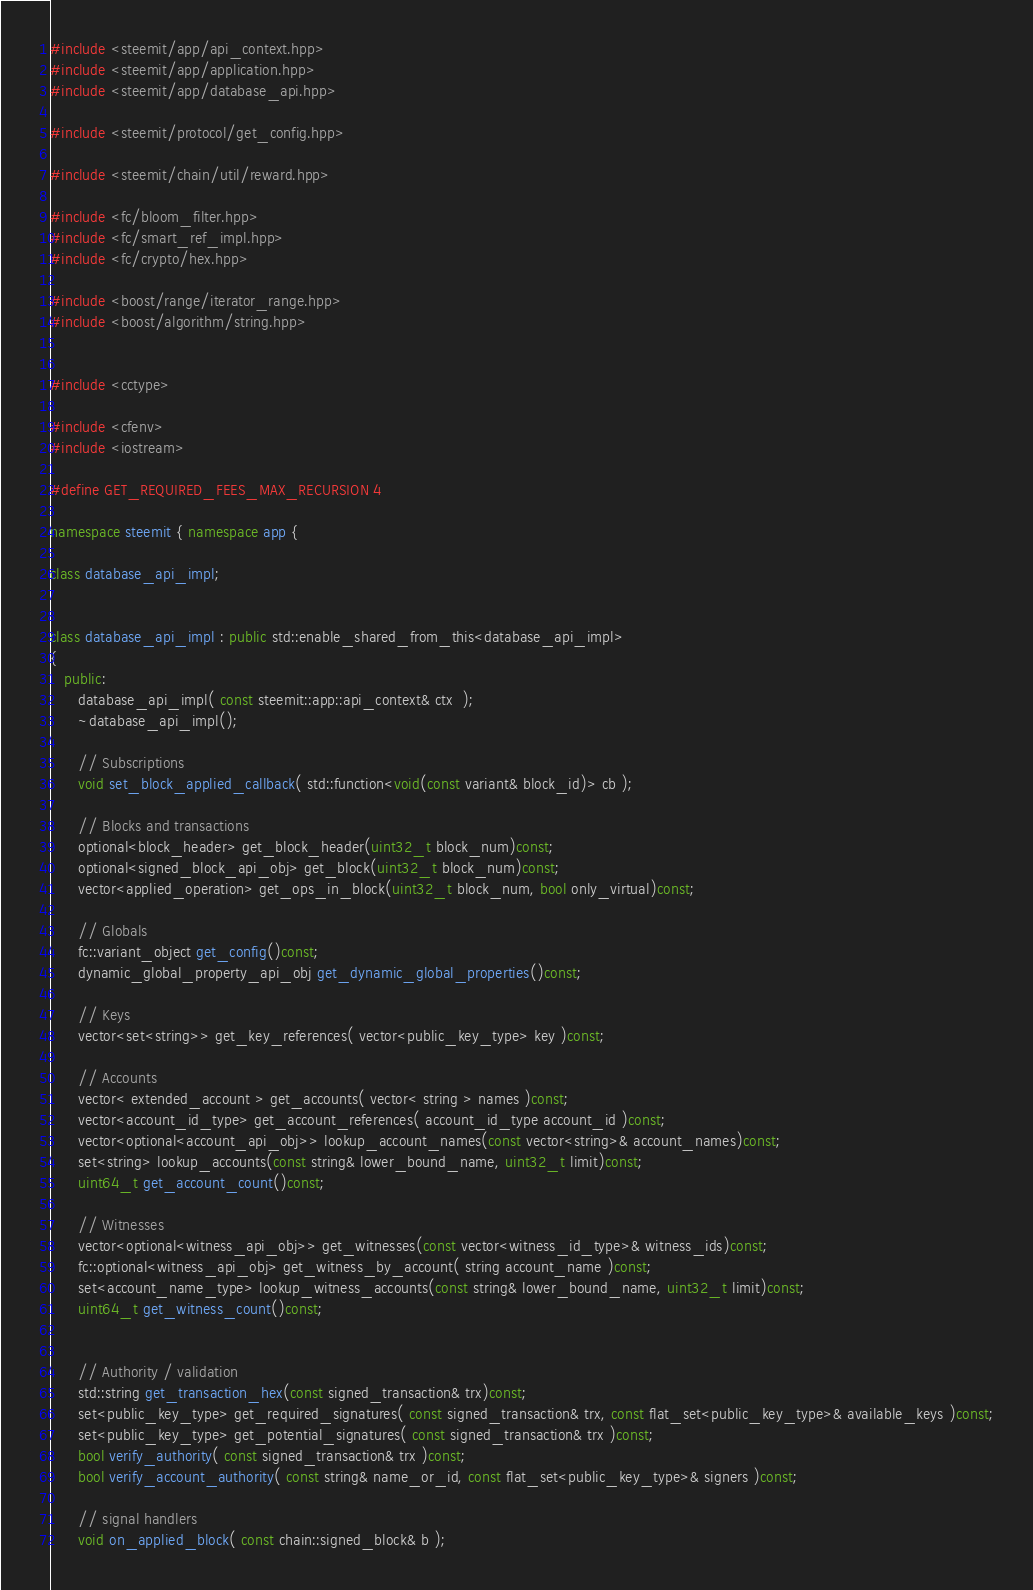Convert code to text. <code><loc_0><loc_0><loc_500><loc_500><_C++_>#include <steemit/app/api_context.hpp>
#include <steemit/app/application.hpp>
#include <steemit/app/database_api.hpp>

#include <steemit/protocol/get_config.hpp>

#include <steemit/chain/util/reward.hpp>

#include <fc/bloom_filter.hpp>
#include <fc/smart_ref_impl.hpp>
#include <fc/crypto/hex.hpp>

#include <boost/range/iterator_range.hpp>
#include <boost/algorithm/string.hpp>


#include <cctype>

#include <cfenv>
#include <iostream>

#define GET_REQUIRED_FEES_MAX_RECURSION 4

namespace steemit { namespace app {

class database_api_impl;


class database_api_impl : public std::enable_shared_from_this<database_api_impl>
{
   public:
      database_api_impl( const steemit::app::api_context& ctx  );
      ~database_api_impl();

      // Subscriptions
      void set_block_applied_callback( std::function<void(const variant& block_id)> cb );

      // Blocks and transactions
      optional<block_header> get_block_header(uint32_t block_num)const;
      optional<signed_block_api_obj> get_block(uint32_t block_num)const;
      vector<applied_operation> get_ops_in_block(uint32_t block_num, bool only_virtual)const;

      // Globals
      fc::variant_object get_config()const;
      dynamic_global_property_api_obj get_dynamic_global_properties()const;

      // Keys
      vector<set<string>> get_key_references( vector<public_key_type> key )const;

      // Accounts
      vector< extended_account > get_accounts( vector< string > names )const;
      vector<account_id_type> get_account_references( account_id_type account_id )const;
      vector<optional<account_api_obj>> lookup_account_names(const vector<string>& account_names)const;
      set<string> lookup_accounts(const string& lower_bound_name, uint32_t limit)const;
      uint64_t get_account_count()const;

      // Witnesses
      vector<optional<witness_api_obj>> get_witnesses(const vector<witness_id_type>& witness_ids)const;
      fc::optional<witness_api_obj> get_witness_by_account( string account_name )const;
      set<account_name_type> lookup_witness_accounts(const string& lower_bound_name, uint32_t limit)const;
      uint64_t get_witness_count()const;


      // Authority / validation
      std::string get_transaction_hex(const signed_transaction& trx)const;
      set<public_key_type> get_required_signatures( const signed_transaction& trx, const flat_set<public_key_type>& available_keys )const;
      set<public_key_type> get_potential_signatures( const signed_transaction& trx )const;
      bool verify_authority( const signed_transaction& trx )const;
      bool verify_account_authority( const string& name_or_id, const flat_set<public_key_type>& signers )const;

      // signal handlers
      void on_applied_block( const chain::signed_block& b );
</code> 